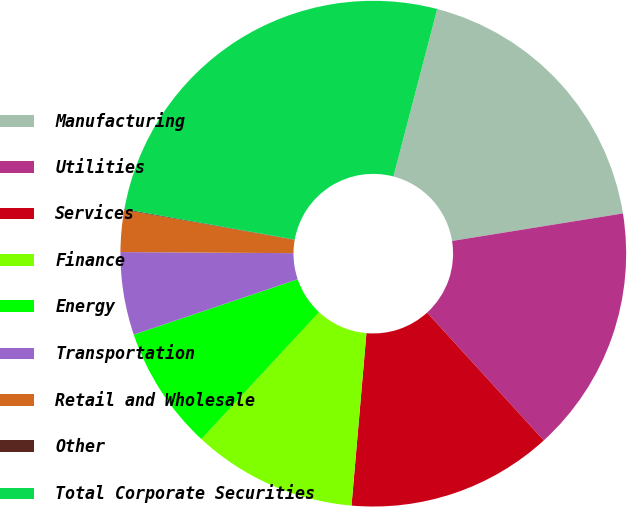<chart> <loc_0><loc_0><loc_500><loc_500><pie_chart><fcel>Manufacturing<fcel>Utilities<fcel>Services<fcel>Finance<fcel>Energy<fcel>Transportation<fcel>Retail and Wholesale<fcel>Other<fcel>Total Corporate Securities<nl><fcel>18.39%<fcel>15.77%<fcel>13.15%<fcel>10.53%<fcel>7.91%<fcel>5.29%<fcel>2.67%<fcel>0.05%<fcel>26.25%<nl></chart> 